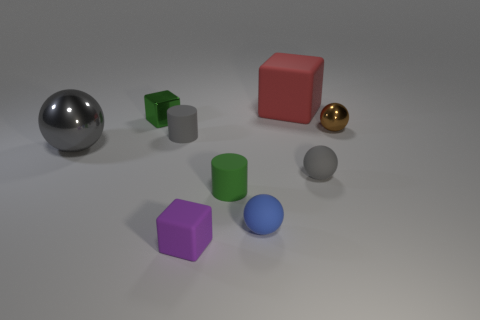Subtract all balls. How many objects are left? 5 Subtract all tiny blocks. How many blocks are left? 1 Subtract 0 gray cubes. How many objects are left? 9 Subtract 1 cylinders. How many cylinders are left? 1 Subtract all gray cylinders. Subtract all purple blocks. How many cylinders are left? 1 Subtract all red cylinders. How many red cubes are left? 1 Subtract all small green matte cylinders. Subtract all gray matte spheres. How many objects are left? 7 Add 8 brown metal balls. How many brown metal balls are left? 9 Add 8 purple shiny balls. How many purple shiny balls exist? 8 Add 1 big cyan matte things. How many objects exist? 10 